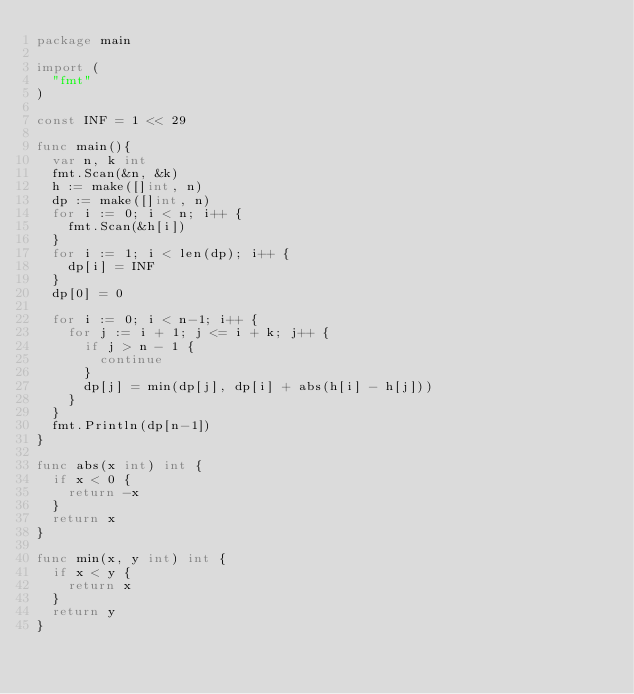<code> <loc_0><loc_0><loc_500><loc_500><_Go_>package main

import (
	"fmt"
)

const INF = 1 << 29

func main(){
	var n, k int
	fmt.Scan(&n, &k)
	h := make([]int, n)
	dp := make([]int, n)
	for i := 0; i < n; i++ {
		fmt.Scan(&h[i])
	}
	for i := 1; i < len(dp); i++ {
		dp[i] = INF
	}
	dp[0] = 0

	for i := 0; i < n-1; i++ {
		for j := i + 1; j <= i + k; j++ {
			if j > n - 1 {
				continue
			}
			dp[j] = min(dp[j], dp[i] + abs(h[i] - h[j]))
		}
	}
	fmt.Println(dp[n-1])
}

func abs(x int) int {
	if x < 0 {
		return -x
	}
	return x
}

func min(x, y int) int {
	if x < y {
		return x
	}
	return y
}</code> 